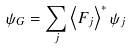Convert formula to latex. <formula><loc_0><loc_0><loc_500><loc_500>\psi _ { G } = \sum _ { j } \left \langle F _ { j } \right \rangle ^ { \ast } \psi _ { j }</formula> 